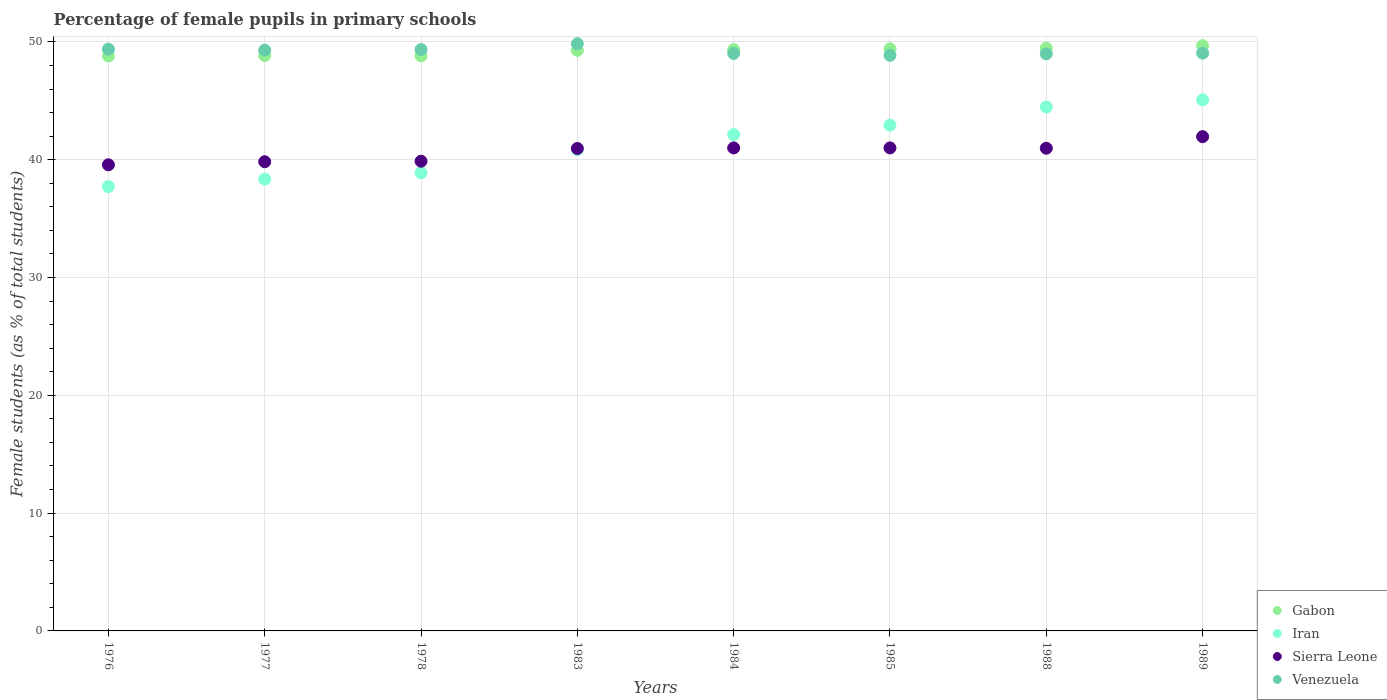What is the percentage of female pupils in primary schools in Iran in 1989?
Your answer should be very brief. 45.08. Across all years, what is the maximum percentage of female pupils in primary schools in Sierra Leone?
Give a very brief answer. 41.96. Across all years, what is the minimum percentage of female pupils in primary schools in Sierra Leone?
Ensure brevity in your answer.  39.57. In which year was the percentage of female pupils in primary schools in Gabon maximum?
Offer a terse response. 1989. In which year was the percentage of female pupils in primary schools in Iran minimum?
Make the answer very short. 1976. What is the total percentage of female pupils in primary schools in Gabon in the graph?
Your answer should be very brief. 393.63. What is the difference between the percentage of female pupils in primary schools in Sierra Leone in 1976 and that in 1977?
Your response must be concise. -0.26. What is the difference between the percentage of female pupils in primary schools in Sierra Leone in 1983 and the percentage of female pupils in primary schools in Iran in 1977?
Provide a succinct answer. 2.6. What is the average percentage of female pupils in primary schools in Iran per year?
Give a very brief answer. 41.3. In the year 1984, what is the difference between the percentage of female pupils in primary schools in Iran and percentage of female pupils in primary schools in Venezuela?
Your response must be concise. -6.89. What is the ratio of the percentage of female pupils in primary schools in Venezuela in 1984 to that in 1988?
Offer a terse response. 1. Is the percentage of female pupils in primary schools in Sierra Leone in 1978 less than that in 1985?
Your response must be concise. Yes. Is the difference between the percentage of female pupils in primary schools in Iran in 1978 and 1983 greater than the difference between the percentage of female pupils in primary schools in Venezuela in 1978 and 1983?
Your response must be concise. No. What is the difference between the highest and the second highest percentage of female pupils in primary schools in Sierra Leone?
Ensure brevity in your answer.  0.96. What is the difference between the highest and the lowest percentage of female pupils in primary schools in Gabon?
Your response must be concise. 0.87. Is it the case that in every year, the sum of the percentage of female pupils in primary schools in Iran and percentage of female pupils in primary schools in Sierra Leone  is greater than the sum of percentage of female pupils in primary schools in Venezuela and percentage of female pupils in primary schools in Gabon?
Offer a very short reply. No. Does the percentage of female pupils in primary schools in Gabon monotonically increase over the years?
Keep it short and to the point. No. How many years are there in the graph?
Make the answer very short. 8. Does the graph contain grids?
Offer a very short reply. Yes. Where does the legend appear in the graph?
Your answer should be compact. Bottom right. How many legend labels are there?
Offer a terse response. 4. How are the legend labels stacked?
Your response must be concise. Vertical. What is the title of the graph?
Ensure brevity in your answer.  Percentage of female pupils in primary schools. What is the label or title of the X-axis?
Your response must be concise. Years. What is the label or title of the Y-axis?
Offer a very short reply. Female students (as % of total students). What is the Female students (as % of total students) in Gabon in 1976?
Provide a short and direct response. 48.8. What is the Female students (as % of total students) of Iran in 1976?
Give a very brief answer. 37.72. What is the Female students (as % of total students) in Sierra Leone in 1976?
Offer a very short reply. 39.57. What is the Female students (as % of total students) in Venezuela in 1976?
Offer a terse response. 49.38. What is the Female students (as % of total students) of Gabon in 1977?
Keep it short and to the point. 48.84. What is the Female students (as % of total students) in Iran in 1977?
Provide a short and direct response. 38.35. What is the Female students (as % of total students) in Sierra Leone in 1977?
Provide a short and direct response. 39.83. What is the Female students (as % of total students) in Venezuela in 1977?
Give a very brief answer. 49.3. What is the Female students (as % of total students) in Gabon in 1978?
Your answer should be compact. 48.81. What is the Female students (as % of total students) in Iran in 1978?
Offer a very short reply. 38.89. What is the Female students (as % of total students) in Sierra Leone in 1978?
Provide a succinct answer. 39.87. What is the Female students (as % of total students) in Venezuela in 1978?
Offer a very short reply. 49.35. What is the Female students (as % of total students) in Gabon in 1983?
Keep it short and to the point. 49.28. What is the Female students (as % of total students) of Iran in 1983?
Provide a succinct answer. 40.85. What is the Female students (as % of total students) of Sierra Leone in 1983?
Your answer should be compact. 40.95. What is the Female students (as % of total students) of Venezuela in 1983?
Give a very brief answer. 49.84. What is the Female students (as % of total students) of Gabon in 1984?
Make the answer very short. 49.34. What is the Female students (as % of total students) of Iran in 1984?
Offer a terse response. 42.13. What is the Female students (as % of total students) of Sierra Leone in 1984?
Offer a very short reply. 41. What is the Female students (as % of total students) in Venezuela in 1984?
Ensure brevity in your answer.  49.02. What is the Female students (as % of total students) of Gabon in 1985?
Your answer should be compact. 49.41. What is the Female students (as % of total students) of Iran in 1985?
Provide a short and direct response. 42.93. What is the Female students (as % of total students) in Sierra Leone in 1985?
Provide a succinct answer. 41. What is the Female students (as % of total students) in Venezuela in 1985?
Keep it short and to the point. 48.86. What is the Female students (as % of total students) in Gabon in 1988?
Make the answer very short. 49.47. What is the Female students (as % of total students) in Iran in 1988?
Provide a short and direct response. 44.48. What is the Female students (as % of total students) of Sierra Leone in 1988?
Make the answer very short. 40.97. What is the Female students (as % of total students) of Venezuela in 1988?
Ensure brevity in your answer.  48.98. What is the Female students (as % of total students) of Gabon in 1989?
Give a very brief answer. 49.68. What is the Female students (as % of total students) in Iran in 1989?
Offer a terse response. 45.08. What is the Female students (as % of total students) in Sierra Leone in 1989?
Keep it short and to the point. 41.96. What is the Female students (as % of total students) in Venezuela in 1989?
Provide a succinct answer. 49.05. Across all years, what is the maximum Female students (as % of total students) in Gabon?
Your answer should be compact. 49.68. Across all years, what is the maximum Female students (as % of total students) of Iran?
Keep it short and to the point. 45.08. Across all years, what is the maximum Female students (as % of total students) of Sierra Leone?
Offer a terse response. 41.96. Across all years, what is the maximum Female students (as % of total students) in Venezuela?
Offer a very short reply. 49.84. Across all years, what is the minimum Female students (as % of total students) of Gabon?
Your response must be concise. 48.8. Across all years, what is the minimum Female students (as % of total students) in Iran?
Give a very brief answer. 37.72. Across all years, what is the minimum Female students (as % of total students) of Sierra Leone?
Provide a short and direct response. 39.57. Across all years, what is the minimum Female students (as % of total students) in Venezuela?
Your answer should be compact. 48.86. What is the total Female students (as % of total students) of Gabon in the graph?
Your answer should be very brief. 393.63. What is the total Female students (as % of total students) of Iran in the graph?
Provide a succinct answer. 330.43. What is the total Female students (as % of total students) in Sierra Leone in the graph?
Make the answer very short. 325.14. What is the total Female students (as % of total students) in Venezuela in the graph?
Give a very brief answer. 393.78. What is the difference between the Female students (as % of total students) in Gabon in 1976 and that in 1977?
Keep it short and to the point. -0.04. What is the difference between the Female students (as % of total students) in Iran in 1976 and that in 1977?
Your answer should be compact. -0.63. What is the difference between the Female students (as % of total students) in Sierra Leone in 1976 and that in 1977?
Provide a succinct answer. -0.26. What is the difference between the Female students (as % of total students) of Venezuela in 1976 and that in 1977?
Your answer should be compact. 0.08. What is the difference between the Female students (as % of total students) in Gabon in 1976 and that in 1978?
Ensure brevity in your answer.  -0.01. What is the difference between the Female students (as % of total students) in Iran in 1976 and that in 1978?
Your answer should be compact. -1.17. What is the difference between the Female students (as % of total students) in Sierra Leone in 1976 and that in 1978?
Offer a terse response. -0.31. What is the difference between the Female students (as % of total students) of Venezuela in 1976 and that in 1978?
Ensure brevity in your answer.  0.04. What is the difference between the Female students (as % of total students) of Gabon in 1976 and that in 1983?
Your answer should be very brief. -0.48. What is the difference between the Female students (as % of total students) in Iran in 1976 and that in 1983?
Make the answer very short. -3.13. What is the difference between the Female students (as % of total students) in Sierra Leone in 1976 and that in 1983?
Provide a short and direct response. -1.39. What is the difference between the Female students (as % of total students) in Venezuela in 1976 and that in 1983?
Provide a short and direct response. -0.46. What is the difference between the Female students (as % of total students) of Gabon in 1976 and that in 1984?
Ensure brevity in your answer.  -0.54. What is the difference between the Female students (as % of total students) in Iran in 1976 and that in 1984?
Ensure brevity in your answer.  -4.41. What is the difference between the Female students (as % of total students) of Sierra Leone in 1976 and that in 1984?
Provide a short and direct response. -1.43. What is the difference between the Female students (as % of total students) in Venezuela in 1976 and that in 1984?
Give a very brief answer. 0.36. What is the difference between the Female students (as % of total students) of Gabon in 1976 and that in 1985?
Make the answer very short. -0.61. What is the difference between the Female students (as % of total students) in Iran in 1976 and that in 1985?
Keep it short and to the point. -5.22. What is the difference between the Female students (as % of total students) in Sierra Leone in 1976 and that in 1985?
Your answer should be compact. -1.43. What is the difference between the Female students (as % of total students) in Venezuela in 1976 and that in 1985?
Make the answer very short. 0.52. What is the difference between the Female students (as % of total students) of Gabon in 1976 and that in 1988?
Ensure brevity in your answer.  -0.67. What is the difference between the Female students (as % of total students) in Iran in 1976 and that in 1988?
Ensure brevity in your answer.  -6.76. What is the difference between the Female students (as % of total students) in Sierra Leone in 1976 and that in 1988?
Keep it short and to the point. -1.41. What is the difference between the Female students (as % of total students) of Venezuela in 1976 and that in 1988?
Ensure brevity in your answer.  0.4. What is the difference between the Female students (as % of total students) in Gabon in 1976 and that in 1989?
Provide a succinct answer. -0.87. What is the difference between the Female students (as % of total students) of Iran in 1976 and that in 1989?
Offer a terse response. -7.36. What is the difference between the Female students (as % of total students) of Sierra Leone in 1976 and that in 1989?
Keep it short and to the point. -2.39. What is the difference between the Female students (as % of total students) of Venezuela in 1976 and that in 1989?
Provide a short and direct response. 0.34. What is the difference between the Female students (as % of total students) of Gabon in 1977 and that in 1978?
Keep it short and to the point. 0.03. What is the difference between the Female students (as % of total students) in Iran in 1977 and that in 1978?
Make the answer very short. -0.54. What is the difference between the Female students (as % of total students) in Sierra Leone in 1977 and that in 1978?
Your answer should be compact. -0.04. What is the difference between the Female students (as % of total students) of Venezuela in 1977 and that in 1978?
Offer a very short reply. -0.05. What is the difference between the Female students (as % of total students) of Gabon in 1977 and that in 1983?
Offer a very short reply. -0.44. What is the difference between the Female students (as % of total students) in Iran in 1977 and that in 1983?
Make the answer very short. -2.5. What is the difference between the Female students (as % of total students) in Sierra Leone in 1977 and that in 1983?
Ensure brevity in your answer.  -1.12. What is the difference between the Female students (as % of total students) of Venezuela in 1977 and that in 1983?
Offer a terse response. -0.54. What is the difference between the Female students (as % of total students) in Gabon in 1977 and that in 1984?
Offer a very short reply. -0.5. What is the difference between the Female students (as % of total students) in Iran in 1977 and that in 1984?
Your response must be concise. -3.78. What is the difference between the Female students (as % of total students) in Sierra Leone in 1977 and that in 1984?
Provide a short and direct response. -1.17. What is the difference between the Female students (as % of total students) of Venezuela in 1977 and that in 1984?
Provide a succinct answer. 0.28. What is the difference between the Female students (as % of total students) of Gabon in 1977 and that in 1985?
Provide a short and direct response. -0.57. What is the difference between the Female students (as % of total students) of Iran in 1977 and that in 1985?
Keep it short and to the point. -4.58. What is the difference between the Female students (as % of total students) of Sierra Leone in 1977 and that in 1985?
Make the answer very short. -1.17. What is the difference between the Female students (as % of total students) of Venezuela in 1977 and that in 1985?
Offer a very short reply. 0.44. What is the difference between the Female students (as % of total students) in Gabon in 1977 and that in 1988?
Keep it short and to the point. -0.63. What is the difference between the Female students (as % of total students) in Iran in 1977 and that in 1988?
Provide a succinct answer. -6.13. What is the difference between the Female students (as % of total students) in Sierra Leone in 1977 and that in 1988?
Provide a short and direct response. -1.14. What is the difference between the Female students (as % of total students) of Venezuela in 1977 and that in 1988?
Keep it short and to the point. 0.32. What is the difference between the Female students (as % of total students) of Gabon in 1977 and that in 1989?
Your response must be concise. -0.83. What is the difference between the Female students (as % of total students) in Iran in 1977 and that in 1989?
Your answer should be compact. -6.73. What is the difference between the Female students (as % of total students) in Sierra Leone in 1977 and that in 1989?
Offer a very short reply. -2.13. What is the difference between the Female students (as % of total students) in Venezuela in 1977 and that in 1989?
Provide a short and direct response. 0.26. What is the difference between the Female students (as % of total students) in Gabon in 1978 and that in 1983?
Make the answer very short. -0.47. What is the difference between the Female students (as % of total students) in Iran in 1978 and that in 1983?
Keep it short and to the point. -1.96. What is the difference between the Female students (as % of total students) in Sierra Leone in 1978 and that in 1983?
Offer a terse response. -1.08. What is the difference between the Female students (as % of total students) of Venezuela in 1978 and that in 1983?
Offer a very short reply. -0.5. What is the difference between the Female students (as % of total students) of Gabon in 1978 and that in 1984?
Give a very brief answer. -0.53. What is the difference between the Female students (as % of total students) of Iran in 1978 and that in 1984?
Provide a succinct answer. -3.24. What is the difference between the Female students (as % of total students) in Sierra Leone in 1978 and that in 1984?
Your answer should be compact. -1.13. What is the difference between the Female students (as % of total students) of Venezuela in 1978 and that in 1984?
Offer a very short reply. 0.33. What is the difference between the Female students (as % of total students) of Gabon in 1978 and that in 1985?
Your answer should be very brief. -0.6. What is the difference between the Female students (as % of total students) in Iran in 1978 and that in 1985?
Offer a very short reply. -4.05. What is the difference between the Female students (as % of total students) in Sierra Leone in 1978 and that in 1985?
Offer a terse response. -1.13. What is the difference between the Female students (as % of total students) of Venezuela in 1978 and that in 1985?
Give a very brief answer. 0.49. What is the difference between the Female students (as % of total students) of Gabon in 1978 and that in 1988?
Your answer should be very brief. -0.66. What is the difference between the Female students (as % of total students) of Iran in 1978 and that in 1988?
Your response must be concise. -5.59. What is the difference between the Female students (as % of total students) of Sierra Leone in 1978 and that in 1988?
Offer a terse response. -1.1. What is the difference between the Female students (as % of total students) in Venezuela in 1978 and that in 1988?
Your response must be concise. 0.37. What is the difference between the Female students (as % of total students) of Gabon in 1978 and that in 1989?
Offer a terse response. -0.87. What is the difference between the Female students (as % of total students) in Iran in 1978 and that in 1989?
Make the answer very short. -6.19. What is the difference between the Female students (as % of total students) of Sierra Leone in 1978 and that in 1989?
Provide a short and direct response. -2.08. What is the difference between the Female students (as % of total students) of Venezuela in 1978 and that in 1989?
Provide a short and direct response. 0.3. What is the difference between the Female students (as % of total students) in Gabon in 1983 and that in 1984?
Your response must be concise. -0.06. What is the difference between the Female students (as % of total students) in Iran in 1983 and that in 1984?
Make the answer very short. -1.28. What is the difference between the Female students (as % of total students) of Sierra Leone in 1983 and that in 1984?
Provide a succinct answer. -0.05. What is the difference between the Female students (as % of total students) of Venezuela in 1983 and that in 1984?
Keep it short and to the point. 0.83. What is the difference between the Female students (as % of total students) of Gabon in 1983 and that in 1985?
Your response must be concise. -0.13. What is the difference between the Female students (as % of total students) of Iran in 1983 and that in 1985?
Give a very brief answer. -2.08. What is the difference between the Female students (as % of total students) of Sierra Leone in 1983 and that in 1985?
Offer a very short reply. -0.05. What is the difference between the Female students (as % of total students) of Gabon in 1983 and that in 1988?
Offer a very short reply. -0.19. What is the difference between the Female students (as % of total students) of Iran in 1983 and that in 1988?
Offer a very short reply. -3.63. What is the difference between the Female students (as % of total students) in Sierra Leone in 1983 and that in 1988?
Keep it short and to the point. -0.02. What is the difference between the Female students (as % of total students) of Venezuela in 1983 and that in 1988?
Give a very brief answer. 0.86. What is the difference between the Female students (as % of total students) in Gabon in 1983 and that in 1989?
Your answer should be very brief. -0.4. What is the difference between the Female students (as % of total students) in Iran in 1983 and that in 1989?
Provide a short and direct response. -4.23. What is the difference between the Female students (as % of total students) of Sierra Leone in 1983 and that in 1989?
Your response must be concise. -1. What is the difference between the Female students (as % of total students) in Venezuela in 1983 and that in 1989?
Your answer should be very brief. 0.8. What is the difference between the Female students (as % of total students) of Gabon in 1984 and that in 1985?
Provide a short and direct response. -0.07. What is the difference between the Female students (as % of total students) in Iran in 1984 and that in 1985?
Offer a very short reply. -0.8. What is the difference between the Female students (as % of total students) in Venezuela in 1984 and that in 1985?
Offer a very short reply. 0.16. What is the difference between the Female students (as % of total students) of Gabon in 1984 and that in 1988?
Give a very brief answer. -0.13. What is the difference between the Female students (as % of total students) of Iran in 1984 and that in 1988?
Your answer should be compact. -2.35. What is the difference between the Female students (as % of total students) in Sierra Leone in 1984 and that in 1988?
Give a very brief answer. 0.03. What is the difference between the Female students (as % of total students) in Venezuela in 1984 and that in 1988?
Your response must be concise. 0.04. What is the difference between the Female students (as % of total students) of Gabon in 1984 and that in 1989?
Your answer should be very brief. -0.34. What is the difference between the Female students (as % of total students) in Iran in 1984 and that in 1989?
Offer a terse response. -2.95. What is the difference between the Female students (as % of total students) of Sierra Leone in 1984 and that in 1989?
Your answer should be very brief. -0.96. What is the difference between the Female students (as % of total students) in Venezuela in 1984 and that in 1989?
Provide a short and direct response. -0.03. What is the difference between the Female students (as % of total students) in Gabon in 1985 and that in 1988?
Offer a very short reply. -0.06. What is the difference between the Female students (as % of total students) of Iran in 1985 and that in 1988?
Make the answer very short. -1.54. What is the difference between the Female students (as % of total students) in Sierra Leone in 1985 and that in 1988?
Your answer should be very brief. 0.03. What is the difference between the Female students (as % of total students) of Venezuela in 1985 and that in 1988?
Your answer should be very brief. -0.12. What is the difference between the Female students (as % of total students) of Gabon in 1985 and that in 1989?
Give a very brief answer. -0.27. What is the difference between the Female students (as % of total students) in Iran in 1985 and that in 1989?
Offer a terse response. -2.15. What is the difference between the Female students (as % of total students) in Sierra Leone in 1985 and that in 1989?
Your response must be concise. -0.96. What is the difference between the Female students (as % of total students) of Venezuela in 1985 and that in 1989?
Make the answer very short. -0.19. What is the difference between the Female students (as % of total students) in Gabon in 1988 and that in 1989?
Keep it short and to the point. -0.21. What is the difference between the Female students (as % of total students) of Iran in 1988 and that in 1989?
Make the answer very short. -0.6. What is the difference between the Female students (as % of total students) of Sierra Leone in 1988 and that in 1989?
Your response must be concise. -0.99. What is the difference between the Female students (as % of total students) of Venezuela in 1988 and that in 1989?
Keep it short and to the point. -0.07. What is the difference between the Female students (as % of total students) in Gabon in 1976 and the Female students (as % of total students) in Iran in 1977?
Keep it short and to the point. 10.45. What is the difference between the Female students (as % of total students) of Gabon in 1976 and the Female students (as % of total students) of Sierra Leone in 1977?
Provide a short and direct response. 8.97. What is the difference between the Female students (as % of total students) of Gabon in 1976 and the Female students (as % of total students) of Venezuela in 1977?
Your response must be concise. -0.5. What is the difference between the Female students (as % of total students) in Iran in 1976 and the Female students (as % of total students) in Sierra Leone in 1977?
Keep it short and to the point. -2.11. What is the difference between the Female students (as % of total students) in Iran in 1976 and the Female students (as % of total students) in Venezuela in 1977?
Provide a succinct answer. -11.58. What is the difference between the Female students (as % of total students) in Sierra Leone in 1976 and the Female students (as % of total students) in Venezuela in 1977?
Offer a very short reply. -9.73. What is the difference between the Female students (as % of total students) in Gabon in 1976 and the Female students (as % of total students) in Iran in 1978?
Give a very brief answer. 9.91. What is the difference between the Female students (as % of total students) in Gabon in 1976 and the Female students (as % of total students) in Sierra Leone in 1978?
Ensure brevity in your answer.  8.93. What is the difference between the Female students (as % of total students) in Gabon in 1976 and the Female students (as % of total students) in Venezuela in 1978?
Make the answer very short. -0.54. What is the difference between the Female students (as % of total students) in Iran in 1976 and the Female students (as % of total students) in Sierra Leone in 1978?
Offer a very short reply. -2.15. What is the difference between the Female students (as % of total students) of Iran in 1976 and the Female students (as % of total students) of Venezuela in 1978?
Make the answer very short. -11.63. What is the difference between the Female students (as % of total students) of Sierra Leone in 1976 and the Female students (as % of total students) of Venezuela in 1978?
Make the answer very short. -9.78. What is the difference between the Female students (as % of total students) in Gabon in 1976 and the Female students (as % of total students) in Iran in 1983?
Give a very brief answer. 7.95. What is the difference between the Female students (as % of total students) in Gabon in 1976 and the Female students (as % of total students) in Sierra Leone in 1983?
Keep it short and to the point. 7.85. What is the difference between the Female students (as % of total students) in Gabon in 1976 and the Female students (as % of total students) in Venezuela in 1983?
Offer a very short reply. -1.04. What is the difference between the Female students (as % of total students) of Iran in 1976 and the Female students (as % of total students) of Sierra Leone in 1983?
Offer a very short reply. -3.23. What is the difference between the Female students (as % of total students) in Iran in 1976 and the Female students (as % of total students) in Venezuela in 1983?
Offer a terse response. -12.13. What is the difference between the Female students (as % of total students) of Sierra Leone in 1976 and the Female students (as % of total students) of Venezuela in 1983?
Your answer should be compact. -10.28. What is the difference between the Female students (as % of total students) of Gabon in 1976 and the Female students (as % of total students) of Iran in 1984?
Give a very brief answer. 6.67. What is the difference between the Female students (as % of total students) in Gabon in 1976 and the Female students (as % of total students) in Sierra Leone in 1984?
Your answer should be compact. 7.8. What is the difference between the Female students (as % of total students) in Gabon in 1976 and the Female students (as % of total students) in Venezuela in 1984?
Your answer should be very brief. -0.22. What is the difference between the Female students (as % of total students) of Iran in 1976 and the Female students (as % of total students) of Sierra Leone in 1984?
Ensure brevity in your answer.  -3.28. What is the difference between the Female students (as % of total students) in Iran in 1976 and the Female students (as % of total students) in Venezuela in 1984?
Keep it short and to the point. -11.3. What is the difference between the Female students (as % of total students) of Sierra Leone in 1976 and the Female students (as % of total students) of Venezuela in 1984?
Ensure brevity in your answer.  -9.45. What is the difference between the Female students (as % of total students) of Gabon in 1976 and the Female students (as % of total students) of Iran in 1985?
Offer a terse response. 5.87. What is the difference between the Female students (as % of total students) in Gabon in 1976 and the Female students (as % of total students) in Sierra Leone in 1985?
Provide a succinct answer. 7.8. What is the difference between the Female students (as % of total students) of Gabon in 1976 and the Female students (as % of total students) of Venezuela in 1985?
Your answer should be compact. -0.06. What is the difference between the Female students (as % of total students) in Iran in 1976 and the Female students (as % of total students) in Sierra Leone in 1985?
Keep it short and to the point. -3.28. What is the difference between the Female students (as % of total students) of Iran in 1976 and the Female students (as % of total students) of Venezuela in 1985?
Ensure brevity in your answer.  -11.14. What is the difference between the Female students (as % of total students) in Sierra Leone in 1976 and the Female students (as % of total students) in Venezuela in 1985?
Your answer should be very brief. -9.29. What is the difference between the Female students (as % of total students) of Gabon in 1976 and the Female students (as % of total students) of Iran in 1988?
Make the answer very short. 4.33. What is the difference between the Female students (as % of total students) of Gabon in 1976 and the Female students (as % of total students) of Sierra Leone in 1988?
Your answer should be very brief. 7.83. What is the difference between the Female students (as % of total students) of Gabon in 1976 and the Female students (as % of total students) of Venezuela in 1988?
Ensure brevity in your answer.  -0.18. What is the difference between the Female students (as % of total students) of Iran in 1976 and the Female students (as % of total students) of Sierra Leone in 1988?
Keep it short and to the point. -3.25. What is the difference between the Female students (as % of total students) in Iran in 1976 and the Female students (as % of total students) in Venezuela in 1988?
Your response must be concise. -11.26. What is the difference between the Female students (as % of total students) of Sierra Leone in 1976 and the Female students (as % of total students) of Venezuela in 1988?
Offer a very short reply. -9.41. What is the difference between the Female students (as % of total students) in Gabon in 1976 and the Female students (as % of total students) in Iran in 1989?
Provide a succinct answer. 3.72. What is the difference between the Female students (as % of total students) in Gabon in 1976 and the Female students (as % of total students) in Sierra Leone in 1989?
Offer a very short reply. 6.85. What is the difference between the Female students (as % of total students) of Gabon in 1976 and the Female students (as % of total students) of Venezuela in 1989?
Ensure brevity in your answer.  -0.24. What is the difference between the Female students (as % of total students) in Iran in 1976 and the Female students (as % of total students) in Sierra Leone in 1989?
Make the answer very short. -4.24. What is the difference between the Female students (as % of total students) in Iran in 1976 and the Female students (as % of total students) in Venezuela in 1989?
Your answer should be compact. -11.33. What is the difference between the Female students (as % of total students) of Sierra Leone in 1976 and the Female students (as % of total students) of Venezuela in 1989?
Give a very brief answer. -9.48. What is the difference between the Female students (as % of total students) of Gabon in 1977 and the Female students (as % of total students) of Iran in 1978?
Provide a succinct answer. 9.95. What is the difference between the Female students (as % of total students) in Gabon in 1977 and the Female students (as % of total students) in Sierra Leone in 1978?
Your answer should be compact. 8.97. What is the difference between the Female students (as % of total students) of Gabon in 1977 and the Female students (as % of total students) of Venezuela in 1978?
Keep it short and to the point. -0.5. What is the difference between the Female students (as % of total students) of Iran in 1977 and the Female students (as % of total students) of Sierra Leone in 1978?
Offer a terse response. -1.52. What is the difference between the Female students (as % of total students) in Iran in 1977 and the Female students (as % of total students) in Venezuela in 1978?
Provide a short and direct response. -11. What is the difference between the Female students (as % of total students) of Sierra Leone in 1977 and the Female students (as % of total students) of Venezuela in 1978?
Ensure brevity in your answer.  -9.52. What is the difference between the Female students (as % of total students) in Gabon in 1977 and the Female students (as % of total students) in Iran in 1983?
Provide a succinct answer. 7.99. What is the difference between the Female students (as % of total students) of Gabon in 1977 and the Female students (as % of total students) of Sierra Leone in 1983?
Give a very brief answer. 7.89. What is the difference between the Female students (as % of total students) in Gabon in 1977 and the Female students (as % of total students) in Venezuela in 1983?
Your response must be concise. -1. What is the difference between the Female students (as % of total students) in Iran in 1977 and the Female students (as % of total students) in Sierra Leone in 1983?
Provide a succinct answer. -2.6. What is the difference between the Female students (as % of total students) in Iran in 1977 and the Female students (as % of total students) in Venezuela in 1983?
Ensure brevity in your answer.  -11.49. What is the difference between the Female students (as % of total students) of Sierra Leone in 1977 and the Female students (as % of total students) of Venezuela in 1983?
Offer a terse response. -10.02. What is the difference between the Female students (as % of total students) in Gabon in 1977 and the Female students (as % of total students) in Iran in 1984?
Provide a succinct answer. 6.71. What is the difference between the Female students (as % of total students) of Gabon in 1977 and the Female students (as % of total students) of Sierra Leone in 1984?
Your answer should be very brief. 7.84. What is the difference between the Female students (as % of total students) in Gabon in 1977 and the Female students (as % of total students) in Venezuela in 1984?
Your response must be concise. -0.18. What is the difference between the Female students (as % of total students) of Iran in 1977 and the Female students (as % of total students) of Sierra Leone in 1984?
Ensure brevity in your answer.  -2.65. What is the difference between the Female students (as % of total students) in Iran in 1977 and the Female students (as % of total students) in Venezuela in 1984?
Make the answer very short. -10.67. What is the difference between the Female students (as % of total students) of Sierra Leone in 1977 and the Female students (as % of total students) of Venezuela in 1984?
Keep it short and to the point. -9.19. What is the difference between the Female students (as % of total students) of Gabon in 1977 and the Female students (as % of total students) of Iran in 1985?
Your answer should be compact. 5.91. What is the difference between the Female students (as % of total students) of Gabon in 1977 and the Female students (as % of total students) of Sierra Leone in 1985?
Provide a succinct answer. 7.84. What is the difference between the Female students (as % of total students) in Gabon in 1977 and the Female students (as % of total students) in Venezuela in 1985?
Give a very brief answer. -0.02. What is the difference between the Female students (as % of total students) in Iran in 1977 and the Female students (as % of total students) in Sierra Leone in 1985?
Offer a very short reply. -2.65. What is the difference between the Female students (as % of total students) in Iran in 1977 and the Female students (as % of total students) in Venezuela in 1985?
Keep it short and to the point. -10.51. What is the difference between the Female students (as % of total students) of Sierra Leone in 1977 and the Female students (as % of total students) of Venezuela in 1985?
Your answer should be very brief. -9.03. What is the difference between the Female students (as % of total students) of Gabon in 1977 and the Female students (as % of total students) of Iran in 1988?
Give a very brief answer. 4.37. What is the difference between the Female students (as % of total students) in Gabon in 1977 and the Female students (as % of total students) in Sierra Leone in 1988?
Your answer should be compact. 7.87. What is the difference between the Female students (as % of total students) in Gabon in 1977 and the Female students (as % of total students) in Venezuela in 1988?
Offer a terse response. -0.14. What is the difference between the Female students (as % of total students) of Iran in 1977 and the Female students (as % of total students) of Sierra Leone in 1988?
Make the answer very short. -2.62. What is the difference between the Female students (as % of total students) in Iran in 1977 and the Female students (as % of total students) in Venezuela in 1988?
Your response must be concise. -10.63. What is the difference between the Female students (as % of total students) in Sierra Leone in 1977 and the Female students (as % of total students) in Venezuela in 1988?
Provide a short and direct response. -9.15. What is the difference between the Female students (as % of total students) in Gabon in 1977 and the Female students (as % of total students) in Iran in 1989?
Give a very brief answer. 3.76. What is the difference between the Female students (as % of total students) of Gabon in 1977 and the Female students (as % of total students) of Sierra Leone in 1989?
Your response must be concise. 6.89. What is the difference between the Female students (as % of total students) in Gabon in 1977 and the Female students (as % of total students) in Venezuela in 1989?
Your answer should be very brief. -0.2. What is the difference between the Female students (as % of total students) in Iran in 1977 and the Female students (as % of total students) in Sierra Leone in 1989?
Provide a short and direct response. -3.61. What is the difference between the Female students (as % of total students) of Iran in 1977 and the Female students (as % of total students) of Venezuela in 1989?
Offer a very short reply. -10.69. What is the difference between the Female students (as % of total students) of Sierra Leone in 1977 and the Female students (as % of total students) of Venezuela in 1989?
Offer a very short reply. -9.22. What is the difference between the Female students (as % of total students) of Gabon in 1978 and the Female students (as % of total students) of Iran in 1983?
Your answer should be compact. 7.96. What is the difference between the Female students (as % of total students) of Gabon in 1978 and the Female students (as % of total students) of Sierra Leone in 1983?
Ensure brevity in your answer.  7.86. What is the difference between the Female students (as % of total students) in Gabon in 1978 and the Female students (as % of total students) in Venezuela in 1983?
Keep it short and to the point. -1.03. What is the difference between the Female students (as % of total students) in Iran in 1978 and the Female students (as % of total students) in Sierra Leone in 1983?
Your answer should be compact. -2.06. What is the difference between the Female students (as % of total students) of Iran in 1978 and the Female students (as % of total students) of Venezuela in 1983?
Provide a succinct answer. -10.96. What is the difference between the Female students (as % of total students) of Sierra Leone in 1978 and the Female students (as % of total students) of Venezuela in 1983?
Your response must be concise. -9.97. What is the difference between the Female students (as % of total students) of Gabon in 1978 and the Female students (as % of total students) of Iran in 1984?
Offer a terse response. 6.68. What is the difference between the Female students (as % of total students) of Gabon in 1978 and the Female students (as % of total students) of Sierra Leone in 1984?
Give a very brief answer. 7.81. What is the difference between the Female students (as % of total students) of Gabon in 1978 and the Female students (as % of total students) of Venezuela in 1984?
Offer a very short reply. -0.21. What is the difference between the Female students (as % of total students) in Iran in 1978 and the Female students (as % of total students) in Sierra Leone in 1984?
Provide a short and direct response. -2.11. What is the difference between the Female students (as % of total students) of Iran in 1978 and the Female students (as % of total students) of Venezuela in 1984?
Offer a terse response. -10.13. What is the difference between the Female students (as % of total students) in Sierra Leone in 1978 and the Female students (as % of total students) in Venezuela in 1984?
Provide a short and direct response. -9.15. What is the difference between the Female students (as % of total students) in Gabon in 1978 and the Female students (as % of total students) in Iran in 1985?
Provide a short and direct response. 5.88. What is the difference between the Female students (as % of total students) of Gabon in 1978 and the Female students (as % of total students) of Sierra Leone in 1985?
Keep it short and to the point. 7.81. What is the difference between the Female students (as % of total students) in Gabon in 1978 and the Female students (as % of total students) in Venezuela in 1985?
Ensure brevity in your answer.  -0.05. What is the difference between the Female students (as % of total students) of Iran in 1978 and the Female students (as % of total students) of Sierra Leone in 1985?
Ensure brevity in your answer.  -2.11. What is the difference between the Female students (as % of total students) in Iran in 1978 and the Female students (as % of total students) in Venezuela in 1985?
Keep it short and to the point. -9.97. What is the difference between the Female students (as % of total students) of Sierra Leone in 1978 and the Female students (as % of total students) of Venezuela in 1985?
Offer a terse response. -8.99. What is the difference between the Female students (as % of total students) of Gabon in 1978 and the Female students (as % of total students) of Iran in 1988?
Offer a very short reply. 4.33. What is the difference between the Female students (as % of total students) of Gabon in 1978 and the Female students (as % of total students) of Sierra Leone in 1988?
Your answer should be very brief. 7.84. What is the difference between the Female students (as % of total students) in Gabon in 1978 and the Female students (as % of total students) in Venezuela in 1988?
Offer a terse response. -0.17. What is the difference between the Female students (as % of total students) of Iran in 1978 and the Female students (as % of total students) of Sierra Leone in 1988?
Offer a terse response. -2.08. What is the difference between the Female students (as % of total students) in Iran in 1978 and the Female students (as % of total students) in Venezuela in 1988?
Provide a short and direct response. -10.09. What is the difference between the Female students (as % of total students) of Sierra Leone in 1978 and the Female students (as % of total students) of Venezuela in 1988?
Your answer should be very brief. -9.11. What is the difference between the Female students (as % of total students) of Gabon in 1978 and the Female students (as % of total students) of Iran in 1989?
Your answer should be very brief. 3.73. What is the difference between the Female students (as % of total students) of Gabon in 1978 and the Female students (as % of total students) of Sierra Leone in 1989?
Keep it short and to the point. 6.85. What is the difference between the Female students (as % of total students) of Gabon in 1978 and the Female students (as % of total students) of Venezuela in 1989?
Offer a terse response. -0.23. What is the difference between the Female students (as % of total students) of Iran in 1978 and the Female students (as % of total students) of Sierra Leone in 1989?
Offer a terse response. -3.07. What is the difference between the Female students (as % of total students) in Iran in 1978 and the Female students (as % of total students) in Venezuela in 1989?
Provide a succinct answer. -10.16. What is the difference between the Female students (as % of total students) in Sierra Leone in 1978 and the Female students (as % of total students) in Venezuela in 1989?
Provide a succinct answer. -9.17. What is the difference between the Female students (as % of total students) of Gabon in 1983 and the Female students (as % of total students) of Iran in 1984?
Your answer should be very brief. 7.15. What is the difference between the Female students (as % of total students) of Gabon in 1983 and the Female students (as % of total students) of Sierra Leone in 1984?
Your answer should be compact. 8.28. What is the difference between the Female students (as % of total students) of Gabon in 1983 and the Female students (as % of total students) of Venezuela in 1984?
Ensure brevity in your answer.  0.26. What is the difference between the Female students (as % of total students) in Iran in 1983 and the Female students (as % of total students) in Sierra Leone in 1984?
Ensure brevity in your answer.  -0.15. What is the difference between the Female students (as % of total students) in Iran in 1983 and the Female students (as % of total students) in Venezuela in 1984?
Your answer should be compact. -8.17. What is the difference between the Female students (as % of total students) in Sierra Leone in 1983 and the Female students (as % of total students) in Venezuela in 1984?
Keep it short and to the point. -8.07. What is the difference between the Female students (as % of total students) in Gabon in 1983 and the Female students (as % of total students) in Iran in 1985?
Offer a very short reply. 6.35. What is the difference between the Female students (as % of total students) of Gabon in 1983 and the Female students (as % of total students) of Sierra Leone in 1985?
Make the answer very short. 8.28. What is the difference between the Female students (as % of total students) of Gabon in 1983 and the Female students (as % of total students) of Venezuela in 1985?
Your answer should be very brief. 0.42. What is the difference between the Female students (as % of total students) of Iran in 1983 and the Female students (as % of total students) of Sierra Leone in 1985?
Your answer should be compact. -0.15. What is the difference between the Female students (as % of total students) in Iran in 1983 and the Female students (as % of total students) in Venezuela in 1985?
Provide a short and direct response. -8.01. What is the difference between the Female students (as % of total students) in Sierra Leone in 1983 and the Female students (as % of total students) in Venezuela in 1985?
Offer a very short reply. -7.91. What is the difference between the Female students (as % of total students) in Gabon in 1983 and the Female students (as % of total students) in Iran in 1988?
Your answer should be very brief. 4.8. What is the difference between the Female students (as % of total students) of Gabon in 1983 and the Female students (as % of total students) of Sierra Leone in 1988?
Keep it short and to the point. 8.31. What is the difference between the Female students (as % of total students) of Gabon in 1983 and the Female students (as % of total students) of Venezuela in 1988?
Provide a succinct answer. 0.3. What is the difference between the Female students (as % of total students) in Iran in 1983 and the Female students (as % of total students) in Sierra Leone in 1988?
Your answer should be very brief. -0.12. What is the difference between the Female students (as % of total students) in Iran in 1983 and the Female students (as % of total students) in Venezuela in 1988?
Make the answer very short. -8.13. What is the difference between the Female students (as % of total students) of Sierra Leone in 1983 and the Female students (as % of total students) of Venezuela in 1988?
Your answer should be compact. -8.03. What is the difference between the Female students (as % of total students) in Gabon in 1983 and the Female students (as % of total students) in Iran in 1989?
Your response must be concise. 4.2. What is the difference between the Female students (as % of total students) in Gabon in 1983 and the Female students (as % of total students) in Sierra Leone in 1989?
Ensure brevity in your answer.  7.33. What is the difference between the Female students (as % of total students) in Gabon in 1983 and the Female students (as % of total students) in Venezuela in 1989?
Offer a terse response. 0.24. What is the difference between the Female students (as % of total students) in Iran in 1983 and the Female students (as % of total students) in Sierra Leone in 1989?
Provide a succinct answer. -1.11. What is the difference between the Female students (as % of total students) of Iran in 1983 and the Female students (as % of total students) of Venezuela in 1989?
Offer a very short reply. -8.2. What is the difference between the Female students (as % of total students) in Sierra Leone in 1983 and the Female students (as % of total students) in Venezuela in 1989?
Ensure brevity in your answer.  -8.09. What is the difference between the Female students (as % of total students) in Gabon in 1984 and the Female students (as % of total students) in Iran in 1985?
Offer a very short reply. 6.4. What is the difference between the Female students (as % of total students) in Gabon in 1984 and the Female students (as % of total students) in Sierra Leone in 1985?
Offer a terse response. 8.34. What is the difference between the Female students (as % of total students) of Gabon in 1984 and the Female students (as % of total students) of Venezuela in 1985?
Your response must be concise. 0.48. What is the difference between the Female students (as % of total students) in Iran in 1984 and the Female students (as % of total students) in Sierra Leone in 1985?
Keep it short and to the point. 1.13. What is the difference between the Female students (as % of total students) in Iran in 1984 and the Female students (as % of total students) in Venezuela in 1985?
Your answer should be compact. -6.73. What is the difference between the Female students (as % of total students) in Sierra Leone in 1984 and the Female students (as % of total students) in Venezuela in 1985?
Your answer should be very brief. -7.86. What is the difference between the Female students (as % of total students) of Gabon in 1984 and the Female students (as % of total students) of Iran in 1988?
Provide a succinct answer. 4.86. What is the difference between the Female students (as % of total students) in Gabon in 1984 and the Female students (as % of total students) in Sierra Leone in 1988?
Offer a terse response. 8.37. What is the difference between the Female students (as % of total students) of Gabon in 1984 and the Female students (as % of total students) of Venezuela in 1988?
Make the answer very short. 0.36. What is the difference between the Female students (as % of total students) in Iran in 1984 and the Female students (as % of total students) in Sierra Leone in 1988?
Offer a very short reply. 1.16. What is the difference between the Female students (as % of total students) in Iran in 1984 and the Female students (as % of total students) in Venezuela in 1988?
Your response must be concise. -6.85. What is the difference between the Female students (as % of total students) in Sierra Leone in 1984 and the Female students (as % of total students) in Venezuela in 1988?
Provide a short and direct response. -7.98. What is the difference between the Female students (as % of total students) of Gabon in 1984 and the Female students (as % of total students) of Iran in 1989?
Provide a succinct answer. 4.26. What is the difference between the Female students (as % of total students) of Gabon in 1984 and the Female students (as % of total students) of Sierra Leone in 1989?
Provide a short and direct response. 7.38. What is the difference between the Female students (as % of total students) of Gabon in 1984 and the Female students (as % of total students) of Venezuela in 1989?
Provide a succinct answer. 0.29. What is the difference between the Female students (as % of total students) of Iran in 1984 and the Female students (as % of total students) of Sierra Leone in 1989?
Make the answer very short. 0.17. What is the difference between the Female students (as % of total students) of Iran in 1984 and the Female students (as % of total students) of Venezuela in 1989?
Provide a succinct answer. -6.91. What is the difference between the Female students (as % of total students) in Sierra Leone in 1984 and the Female students (as % of total students) in Venezuela in 1989?
Offer a terse response. -8.05. What is the difference between the Female students (as % of total students) in Gabon in 1985 and the Female students (as % of total students) in Iran in 1988?
Give a very brief answer. 4.93. What is the difference between the Female students (as % of total students) of Gabon in 1985 and the Female students (as % of total students) of Sierra Leone in 1988?
Your response must be concise. 8.44. What is the difference between the Female students (as % of total students) of Gabon in 1985 and the Female students (as % of total students) of Venezuela in 1988?
Your response must be concise. 0.43. What is the difference between the Female students (as % of total students) in Iran in 1985 and the Female students (as % of total students) in Sierra Leone in 1988?
Give a very brief answer. 1.96. What is the difference between the Female students (as % of total students) of Iran in 1985 and the Female students (as % of total students) of Venezuela in 1988?
Give a very brief answer. -6.05. What is the difference between the Female students (as % of total students) of Sierra Leone in 1985 and the Female students (as % of total students) of Venezuela in 1988?
Make the answer very short. -7.98. What is the difference between the Female students (as % of total students) in Gabon in 1985 and the Female students (as % of total students) in Iran in 1989?
Keep it short and to the point. 4.33. What is the difference between the Female students (as % of total students) in Gabon in 1985 and the Female students (as % of total students) in Sierra Leone in 1989?
Provide a succinct answer. 7.45. What is the difference between the Female students (as % of total students) in Gabon in 1985 and the Female students (as % of total students) in Venezuela in 1989?
Your answer should be very brief. 0.36. What is the difference between the Female students (as % of total students) in Iran in 1985 and the Female students (as % of total students) in Sierra Leone in 1989?
Your answer should be compact. 0.98. What is the difference between the Female students (as % of total students) of Iran in 1985 and the Female students (as % of total students) of Venezuela in 1989?
Ensure brevity in your answer.  -6.11. What is the difference between the Female students (as % of total students) of Sierra Leone in 1985 and the Female students (as % of total students) of Venezuela in 1989?
Your answer should be very brief. -8.05. What is the difference between the Female students (as % of total students) of Gabon in 1988 and the Female students (as % of total students) of Iran in 1989?
Provide a short and direct response. 4.39. What is the difference between the Female students (as % of total students) in Gabon in 1988 and the Female students (as % of total students) in Sierra Leone in 1989?
Your answer should be compact. 7.51. What is the difference between the Female students (as % of total students) in Gabon in 1988 and the Female students (as % of total students) in Venezuela in 1989?
Ensure brevity in your answer.  0.42. What is the difference between the Female students (as % of total students) in Iran in 1988 and the Female students (as % of total students) in Sierra Leone in 1989?
Ensure brevity in your answer.  2.52. What is the difference between the Female students (as % of total students) of Iran in 1988 and the Female students (as % of total students) of Venezuela in 1989?
Ensure brevity in your answer.  -4.57. What is the difference between the Female students (as % of total students) of Sierra Leone in 1988 and the Female students (as % of total students) of Venezuela in 1989?
Your answer should be compact. -8.07. What is the average Female students (as % of total students) in Gabon per year?
Offer a very short reply. 49.2. What is the average Female students (as % of total students) of Iran per year?
Ensure brevity in your answer.  41.3. What is the average Female students (as % of total students) of Sierra Leone per year?
Your response must be concise. 40.64. What is the average Female students (as % of total students) in Venezuela per year?
Provide a succinct answer. 49.22. In the year 1976, what is the difference between the Female students (as % of total students) of Gabon and Female students (as % of total students) of Iran?
Offer a very short reply. 11.08. In the year 1976, what is the difference between the Female students (as % of total students) of Gabon and Female students (as % of total students) of Sierra Leone?
Ensure brevity in your answer.  9.24. In the year 1976, what is the difference between the Female students (as % of total students) in Gabon and Female students (as % of total students) in Venezuela?
Your answer should be compact. -0.58. In the year 1976, what is the difference between the Female students (as % of total students) in Iran and Female students (as % of total students) in Sierra Leone?
Your response must be concise. -1.85. In the year 1976, what is the difference between the Female students (as % of total students) in Iran and Female students (as % of total students) in Venezuela?
Your answer should be very brief. -11.66. In the year 1976, what is the difference between the Female students (as % of total students) in Sierra Leone and Female students (as % of total students) in Venezuela?
Your response must be concise. -9.82. In the year 1977, what is the difference between the Female students (as % of total students) in Gabon and Female students (as % of total students) in Iran?
Ensure brevity in your answer.  10.49. In the year 1977, what is the difference between the Female students (as % of total students) in Gabon and Female students (as % of total students) in Sierra Leone?
Your response must be concise. 9.01. In the year 1977, what is the difference between the Female students (as % of total students) in Gabon and Female students (as % of total students) in Venezuela?
Keep it short and to the point. -0.46. In the year 1977, what is the difference between the Female students (as % of total students) in Iran and Female students (as % of total students) in Sierra Leone?
Keep it short and to the point. -1.48. In the year 1977, what is the difference between the Female students (as % of total students) in Iran and Female students (as % of total students) in Venezuela?
Your answer should be compact. -10.95. In the year 1977, what is the difference between the Female students (as % of total students) in Sierra Leone and Female students (as % of total students) in Venezuela?
Your answer should be very brief. -9.47. In the year 1978, what is the difference between the Female students (as % of total students) of Gabon and Female students (as % of total students) of Iran?
Your response must be concise. 9.92. In the year 1978, what is the difference between the Female students (as % of total students) in Gabon and Female students (as % of total students) in Sierra Leone?
Offer a very short reply. 8.94. In the year 1978, what is the difference between the Female students (as % of total students) of Gabon and Female students (as % of total students) of Venezuela?
Your response must be concise. -0.54. In the year 1978, what is the difference between the Female students (as % of total students) in Iran and Female students (as % of total students) in Sierra Leone?
Give a very brief answer. -0.98. In the year 1978, what is the difference between the Female students (as % of total students) of Iran and Female students (as % of total students) of Venezuela?
Keep it short and to the point. -10.46. In the year 1978, what is the difference between the Female students (as % of total students) of Sierra Leone and Female students (as % of total students) of Venezuela?
Give a very brief answer. -9.48. In the year 1983, what is the difference between the Female students (as % of total students) in Gabon and Female students (as % of total students) in Iran?
Your response must be concise. 8.43. In the year 1983, what is the difference between the Female students (as % of total students) of Gabon and Female students (as % of total students) of Sierra Leone?
Give a very brief answer. 8.33. In the year 1983, what is the difference between the Female students (as % of total students) in Gabon and Female students (as % of total students) in Venezuela?
Make the answer very short. -0.56. In the year 1983, what is the difference between the Female students (as % of total students) in Iran and Female students (as % of total students) in Sierra Leone?
Your response must be concise. -0.1. In the year 1983, what is the difference between the Female students (as % of total students) of Iran and Female students (as % of total students) of Venezuela?
Your response must be concise. -8.99. In the year 1983, what is the difference between the Female students (as % of total students) of Sierra Leone and Female students (as % of total students) of Venezuela?
Provide a succinct answer. -8.89. In the year 1984, what is the difference between the Female students (as % of total students) of Gabon and Female students (as % of total students) of Iran?
Offer a terse response. 7.21. In the year 1984, what is the difference between the Female students (as % of total students) in Gabon and Female students (as % of total students) in Sierra Leone?
Provide a succinct answer. 8.34. In the year 1984, what is the difference between the Female students (as % of total students) of Gabon and Female students (as % of total students) of Venezuela?
Provide a short and direct response. 0.32. In the year 1984, what is the difference between the Female students (as % of total students) in Iran and Female students (as % of total students) in Sierra Leone?
Give a very brief answer. 1.13. In the year 1984, what is the difference between the Female students (as % of total students) in Iran and Female students (as % of total students) in Venezuela?
Your response must be concise. -6.89. In the year 1984, what is the difference between the Female students (as % of total students) in Sierra Leone and Female students (as % of total students) in Venezuela?
Offer a very short reply. -8.02. In the year 1985, what is the difference between the Female students (as % of total students) in Gabon and Female students (as % of total students) in Iran?
Offer a terse response. 6.47. In the year 1985, what is the difference between the Female students (as % of total students) of Gabon and Female students (as % of total students) of Sierra Leone?
Provide a succinct answer. 8.41. In the year 1985, what is the difference between the Female students (as % of total students) in Gabon and Female students (as % of total students) in Venezuela?
Your answer should be compact. 0.55. In the year 1985, what is the difference between the Female students (as % of total students) of Iran and Female students (as % of total students) of Sierra Leone?
Offer a very short reply. 1.93. In the year 1985, what is the difference between the Female students (as % of total students) in Iran and Female students (as % of total students) in Venezuela?
Your answer should be compact. -5.93. In the year 1985, what is the difference between the Female students (as % of total students) in Sierra Leone and Female students (as % of total students) in Venezuela?
Give a very brief answer. -7.86. In the year 1988, what is the difference between the Female students (as % of total students) of Gabon and Female students (as % of total students) of Iran?
Offer a terse response. 4.99. In the year 1988, what is the difference between the Female students (as % of total students) in Gabon and Female students (as % of total students) in Sierra Leone?
Offer a terse response. 8.5. In the year 1988, what is the difference between the Female students (as % of total students) of Gabon and Female students (as % of total students) of Venezuela?
Your answer should be very brief. 0.49. In the year 1988, what is the difference between the Female students (as % of total students) of Iran and Female students (as % of total students) of Sierra Leone?
Provide a succinct answer. 3.51. In the year 1988, what is the difference between the Female students (as % of total students) in Iran and Female students (as % of total students) in Venezuela?
Provide a short and direct response. -4.5. In the year 1988, what is the difference between the Female students (as % of total students) of Sierra Leone and Female students (as % of total students) of Venezuela?
Provide a succinct answer. -8.01. In the year 1989, what is the difference between the Female students (as % of total students) in Gabon and Female students (as % of total students) in Iran?
Give a very brief answer. 4.6. In the year 1989, what is the difference between the Female students (as % of total students) of Gabon and Female students (as % of total students) of Sierra Leone?
Ensure brevity in your answer.  7.72. In the year 1989, what is the difference between the Female students (as % of total students) of Gabon and Female students (as % of total students) of Venezuela?
Provide a succinct answer. 0.63. In the year 1989, what is the difference between the Female students (as % of total students) of Iran and Female students (as % of total students) of Sierra Leone?
Ensure brevity in your answer.  3.13. In the year 1989, what is the difference between the Female students (as % of total students) of Iran and Female students (as % of total students) of Venezuela?
Keep it short and to the point. -3.96. In the year 1989, what is the difference between the Female students (as % of total students) in Sierra Leone and Female students (as % of total students) in Venezuela?
Your response must be concise. -7.09. What is the ratio of the Female students (as % of total students) in Iran in 1976 to that in 1977?
Offer a terse response. 0.98. What is the ratio of the Female students (as % of total students) of Sierra Leone in 1976 to that in 1977?
Provide a succinct answer. 0.99. What is the ratio of the Female students (as % of total students) in Gabon in 1976 to that in 1978?
Your answer should be very brief. 1. What is the ratio of the Female students (as % of total students) in Iran in 1976 to that in 1978?
Provide a short and direct response. 0.97. What is the ratio of the Female students (as % of total students) in Sierra Leone in 1976 to that in 1978?
Provide a short and direct response. 0.99. What is the ratio of the Female students (as % of total students) in Venezuela in 1976 to that in 1978?
Your answer should be compact. 1. What is the ratio of the Female students (as % of total students) of Gabon in 1976 to that in 1983?
Your answer should be compact. 0.99. What is the ratio of the Female students (as % of total students) of Iran in 1976 to that in 1983?
Offer a terse response. 0.92. What is the ratio of the Female students (as % of total students) of Sierra Leone in 1976 to that in 1983?
Provide a succinct answer. 0.97. What is the ratio of the Female students (as % of total students) in Venezuela in 1976 to that in 1983?
Provide a short and direct response. 0.99. What is the ratio of the Female students (as % of total students) of Gabon in 1976 to that in 1984?
Make the answer very short. 0.99. What is the ratio of the Female students (as % of total students) in Iran in 1976 to that in 1984?
Your answer should be compact. 0.9. What is the ratio of the Female students (as % of total students) of Venezuela in 1976 to that in 1984?
Provide a succinct answer. 1.01. What is the ratio of the Female students (as % of total students) in Iran in 1976 to that in 1985?
Offer a very short reply. 0.88. What is the ratio of the Female students (as % of total students) of Sierra Leone in 1976 to that in 1985?
Your response must be concise. 0.96. What is the ratio of the Female students (as % of total students) in Venezuela in 1976 to that in 1985?
Your answer should be very brief. 1.01. What is the ratio of the Female students (as % of total students) of Gabon in 1976 to that in 1988?
Provide a succinct answer. 0.99. What is the ratio of the Female students (as % of total students) of Iran in 1976 to that in 1988?
Offer a very short reply. 0.85. What is the ratio of the Female students (as % of total students) of Sierra Leone in 1976 to that in 1988?
Give a very brief answer. 0.97. What is the ratio of the Female students (as % of total students) of Venezuela in 1976 to that in 1988?
Give a very brief answer. 1.01. What is the ratio of the Female students (as % of total students) in Gabon in 1976 to that in 1989?
Offer a terse response. 0.98. What is the ratio of the Female students (as % of total students) of Iran in 1976 to that in 1989?
Provide a short and direct response. 0.84. What is the ratio of the Female students (as % of total students) in Sierra Leone in 1976 to that in 1989?
Provide a succinct answer. 0.94. What is the ratio of the Female students (as % of total students) of Venezuela in 1976 to that in 1989?
Your answer should be very brief. 1.01. What is the ratio of the Female students (as % of total students) of Iran in 1977 to that in 1978?
Keep it short and to the point. 0.99. What is the ratio of the Female students (as % of total students) in Sierra Leone in 1977 to that in 1978?
Ensure brevity in your answer.  1. What is the ratio of the Female students (as % of total students) in Iran in 1977 to that in 1983?
Offer a very short reply. 0.94. What is the ratio of the Female students (as % of total students) of Sierra Leone in 1977 to that in 1983?
Make the answer very short. 0.97. What is the ratio of the Female students (as % of total students) in Iran in 1977 to that in 1984?
Make the answer very short. 0.91. What is the ratio of the Female students (as % of total students) in Sierra Leone in 1977 to that in 1984?
Give a very brief answer. 0.97. What is the ratio of the Female students (as % of total students) in Iran in 1977 to that in 1985?
Your response must be concise. 0.89. What is the ratio of the Female students (as % of total students) of Sierra Leone in 1977 to that in 1985?
Your answer should be compact. 0.97. What is the ratio of the Female students (as % of total students) in Gabon in 1977 to that in 1988?
Provide a succinct answer. 0.99. What is the ratio of the Female students (as % of total students) of Iran in 1977 to that in 1988?
Your response must be concise. 0.86. What is the ratio of the Female students (as % of total students) of Sierra Leone in 1977 to that in 1988?
Make the answer very short. 0.97. What is the ratio of the Female students (as % of total students) of Venezuela in 1977 to that in 1988?
Make the answer very short. 1.01. What is the ratio of the Female students (as % of total students) in Gabon in 1977 to that in 1989?
Your answer should be very brief. 0.98. What is the ratio of the Female students (as % of total students) of Iran in 1977 to that in 1989?
Provide a short and direct response. 0.85. What is the ratio of the Female students (as % of total students) in Sierra Leone in 1977 to that in 1989?
Keep it short and to the point. 0.95. What is the ratio of the Female students (as % of total students) of Sierra Leone in 1978 to that in 1983?
Provide a short and direct response. 0.97. What is the ratio of the Female students (as % of total students) in Venezuela in 1978 to that in 1983?
Make the answer very short. 0.99. What is the ratio of the Female students (as % of total students) in Gabon in 1978 to that in 1984?
Provide a succinct answer. 0.99. What is the ratio of the Female students (as % of total students) of Iran in 1978 to that in 1984?
Your answer should be very brief. 0.92. What is the ratio of the Female students (as % of total students) in Sierra Leone in 1978 to that in 1984?
Provide a short and direct response. 0.97. What is the ratio of the Female students (as % of total students) of Venezuela in 1978 to that in 1984?
Keep it short and to the point. 1.01. What is the ratio of the Female students (as % of total students) of Gabon in 1978 to that in 1985?
Your answer should be very brief. 0.99. What is the ratio of the Female students (as % of total students) of Iran in 1978 to that in 1985?
Offer a very short reply. 0.91. What is the ratio of the Female students (as % of total students) of Sierra Leone in 1978 to that in 1985?
Ensure brevity in your answer.  0.97. What is the ratio of the Female students (as % of total students) of Venezuela in 1978 to that in 1985?
Provide a short and direct response. 1.01. What is the ratio of the Female students (as % of total students) of Gabon in 1978 to that in 1988?
Make the answer very short. 0.99. What is the ratio of the Female students (as % of total students) of Iran in 1978 to that in 1988?
Offer a very short reply. 0.87. What is the ratio of the Female students (as % of total students) in Sierra Leone in 1978 to that in 1988?
Provide a succinct answer. 0.97. What is the ratio of the Female students (as % of total students) in Venezuela in 1978 to that in 1988?
Your answer should be compact. 1.01. What is the ratio of the Female students (as % of total students) of Gabon in 1978 to that in 1989?
Make the answer very short. 0.98. What is the ratio of the Female students (as % of total students) in Iran in 1978 to that in 1989?
Your response must be concise. 0.86. What is the ratio of the Female students (as % of total students) of Sierra Leone in 1978 to that in 1989?
Keep it short and to the point. 0.95. What is the ratio of the Female students (as % of total students) of Iran in 1983 to that in 1984?
Ensure brevity in your answer.  0.97. What is the ratio of the Female students (as % of total students) of Venezuela in 1983 to that in 1984?
Ensure brevity in your answer.  1.02. What is the ratio of the Female students (as % of total students) in Iran in 1983 to that in 1985?
Give a very brief answer. 0.95. What is the ratio of the Female students (as % of total students) of Sierra Leone in 1983 to that in 1985?
Keep it short and to the point. 1. What is the ratio of the Female students (as % of total students) in Venezuela in 1983 to that in 1985?
Ensure brevity in your answer.  1.02. What is the ratio of the Female students (as % of total students) in Iran in 1983 to that in 1988?
Provide a short and direct response. 0.92. What is the ratio of the Female students (as % of total students) of Sierra Leone in 1983 to that in 1988?
Give a very brief answer. 1. What is the ratio of the Female students (as % of total students) of Venezuela in 1983 to that in 1988?
Your answer should be very brief. 1.02. What is the ratio of the Female students (as % of total students) of Gabon in 1983 to that in 1989?
Provide a succinct answer. 0.99. What is the ratio of the Female students (as % of total students) in Iran in 1983 to that in 1989?
Offer a terse response. 0.91. What is the ratio of the Female students (as % of total students) of Sierra Leone in 1983 to that in 1989?
Your answer should be very brief. 0.98. What is the ratio of the Female students (as % of total students) of Venezuela in 1983 to that in 1989?
Provide a short and direct response. 1.02. What is the ratio of the Female students (as % of total students) of Iran in 1984 to that in 1985?
Offer a very short reply. 0.98. What is the ratio of the Female students (as % of total students) of Gabon in 1984 to that in 1988?
Your response must be concise. 1. What is the ratio of the Female students (as % of total students) in Iran in 1984 to that in 1988?
Keep it short and to the point. 0.95. What is the ratio of the Female students (as % of total students) of Gabon in 1984 to that in 1989?
Provide a succinct answer. 0.99. What is the ratio of the Female students (as % of total students) in Iran in 1984 to that in 1989?
Provide a short and direct response. 0.93. What is the ratio of the Female students (as % of total students) in Sierra Leone in 1984 to that in 1989?
Provide a short and direct response. 0.98. What is the ratio of the Female students (as % of total students) in Venezuela in 1984 to that in 1989?
Provide a short and direct response. 1. What is the ratio of the Female students (as % of total students) in Gabon in 1985 to that in 1988?
Offer a very short reply. 1. What is the ratio of the Female students (as % of total students) of Iran in 1985 to that in 1988?
Give a very brief answer. 0.97. What is the ratio of the Female students (as % of total students) of Venezuela in 1985 to that in 1988?
Ensure brevity in your answer.  1. What is the ratio of the Female students (as % of total students) of Sierra Leone in 1985 to that in 1989?
Offer a very short reply. 0.98. What is the ratio of the Female students (as % of total students) of Venezuela in 1985 to that in 1989?
Offer a very short reply. 1. What is the ratio of the Female students (as % of total students) of Gabon in 1988 to that in 1989?
Keep it short and to the point. 1. What is the ratio of the Female students (as % of total students) of Iran in 1988 to that in 1989?
Your answer should be very brief. 0.99. What is the ratio of the Female students (as % of total students) of Sierra Leone in 1988 to that in 1989?
Keep it short and to the point. 0.98. What is the difference between the highest and the second highest Female students (as % of total students) in Gabon?
Ensure brevity in your answer.  0.21. What is the difference between the highest and the second highest Female students (as % of total students) in Iran?
Ensure brevity in your answer.  0.6. What is the difference between the highest and the second highest Female students (as % of total students) of Sierra Leone?
Ensure brevity in your answer.  0.96. What is the difference between the highest and the second highest Female students (as % of total students) of Venezuela?
Your answer should be very brief. 0.46. What is the difference between the highest and the lowest Female students (as % of total students) of Gabon?
Your response must be concise. 0.87. What is the difference between the highest and the lowest Female students (as % of total students) of Iran?
Your response must be concise. 7.36. What is the difference between the highest and the lowest Female students (as % of total students) in Sierra Leone?
Your answer should be very brief. 2.39. What is the difference between the highest and the lowest Female students (as % of total students) of Venezuela?
Provide a succinct answer. 0.98. 